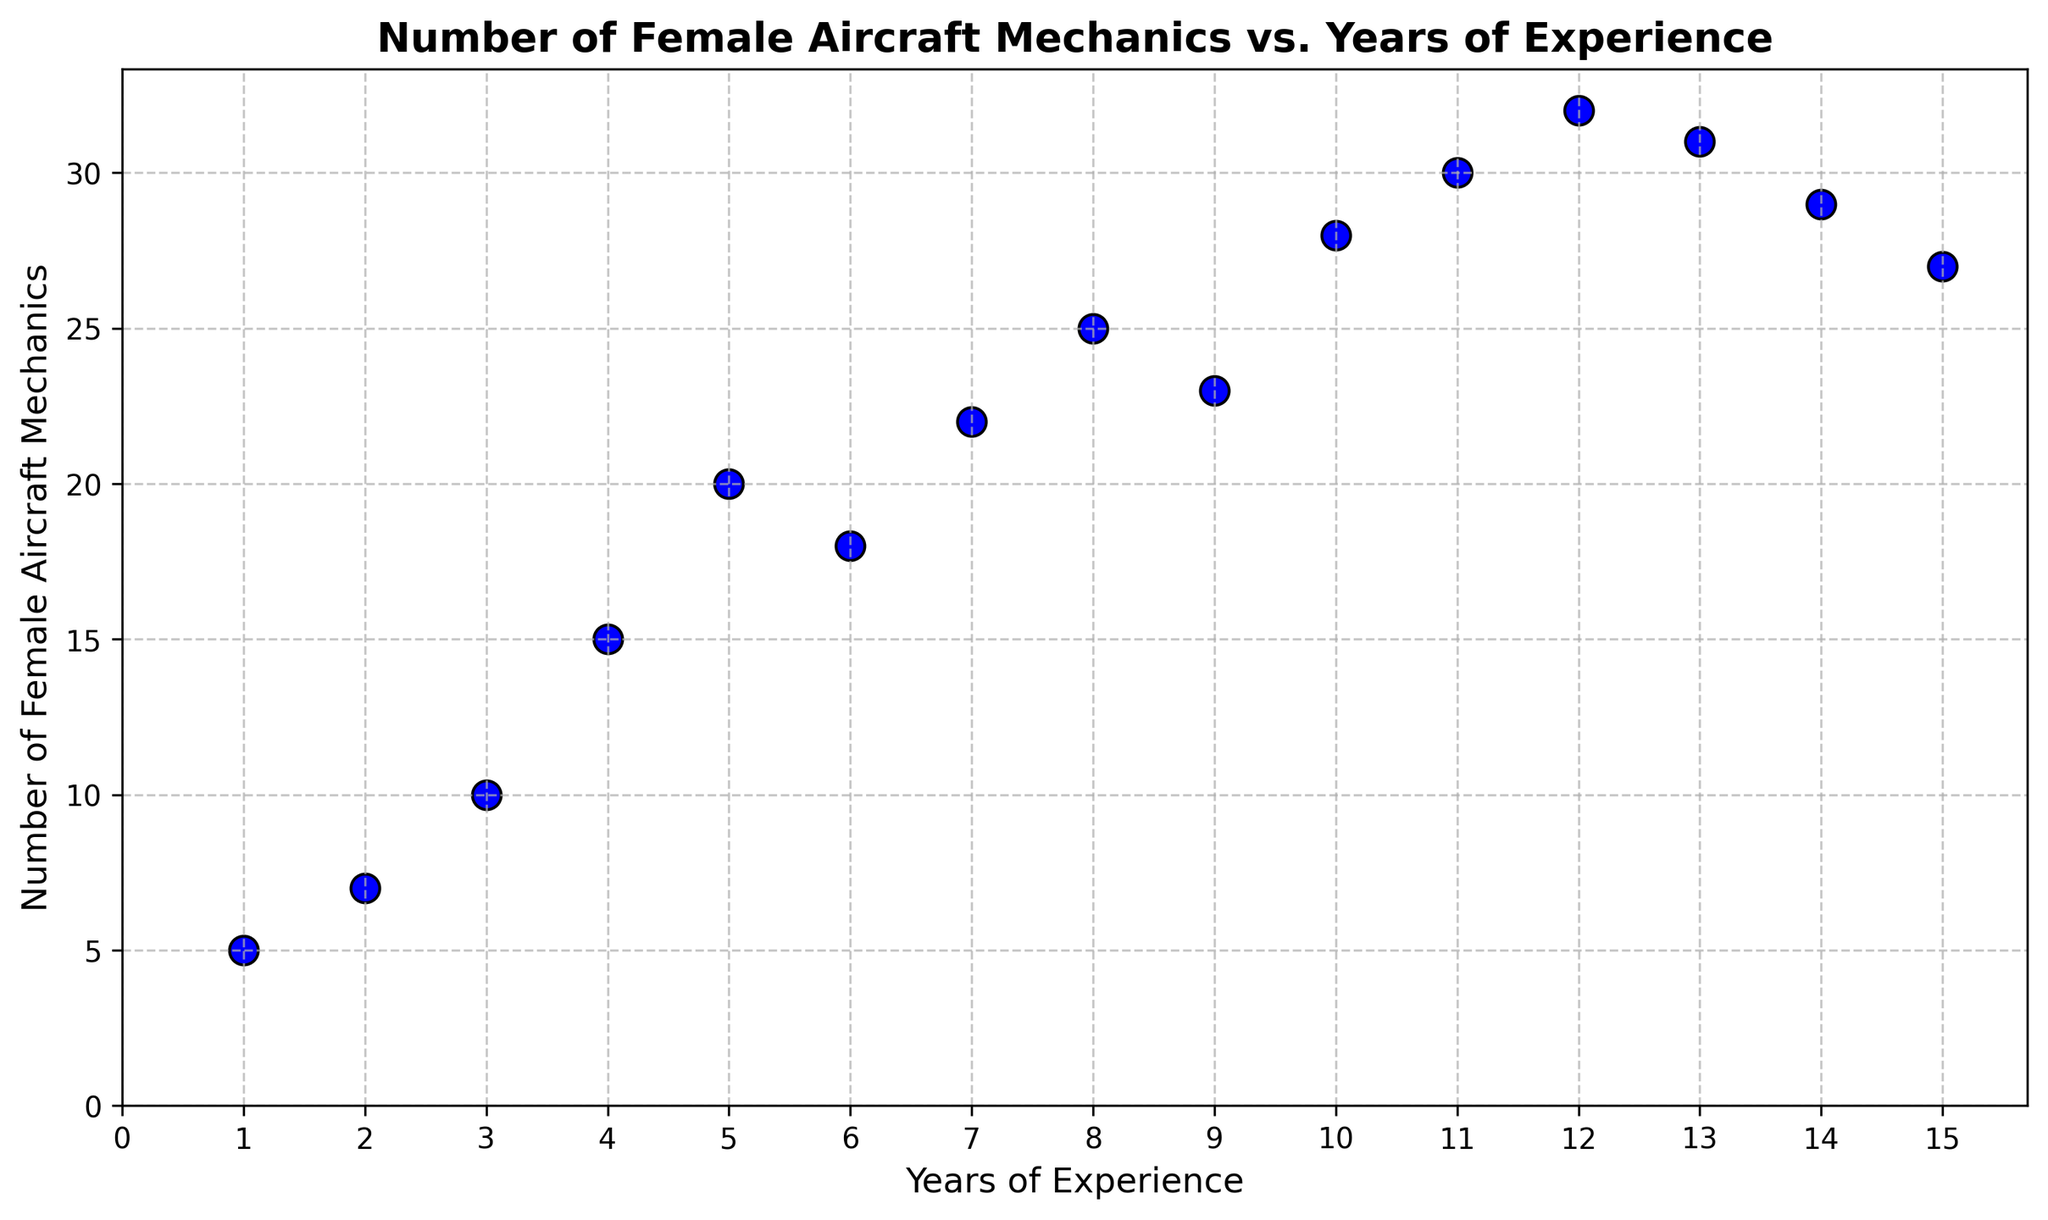What is the general trend of the number of female aircraft mechanics with increasing years of experience? The general trend is observed by looking at the direction of the scatter points from left to right. There is an upward trend with some fluctuations, indicating that the number of female aircraft mechanics generally increases with years of experience but reaches a peak and then slightly declines.
Answer: Increases initially, peaks, then slightly declines What is the minimum number of female aircraft mechanics, and at how many years of experience does this occur? To find the minimum, look for the lowest point on the y-axis. The minimum number of 5 mechanics occurs at 1 year of experience.
Answer: 5, at 1 year How many female aircraft mechanics are there at the mid-point of the data range in terms of years of experience? The midpoint for the years of experience is (1+15)/2 = 8. At 8 years of experience, the number of female aircraft mechanics is 25, as shown by the scatter point.
Answer: 25 Which single year of experience has the highest number of female aircraft mechanics? Identify the highest scatter point on the y-axis. This corresponds to the year with the largest value of female aircraft mechanics, which is 32 at 12 years of experience.
Answer: 32, at 12 years Is the number of female aircraft mechanics at 10 years of experience greater than that at 5 years? Compare the height of the scatter points for 5 and 10 years on the y-axis. At 5 years there are 20 mechanics, and at 10 years there are 28 mechanics. So, 10 years has a greater number.
Answer: Yes What is the average number of female aircraft mechanics for the first 5 years of experience (1 to 5 years)? Sum the values for the first 5 years (5 + 7 + 10 + 15 + 20 = 57) and divide by 5. The average is 57/5 = 11.4.
Answer: 11.4 By how much does the number of female aircraft mechanics increase from 1 to 3 years of experience? Subtract the number at 1 year from the number at 3 years (10 - 5 = 5). Therefore, the increase is 5 mechanics.
Answer: 5 Does the number of female aircraft mechanics ever decrease with increasing years of experience? If so, at which points does this occur? Compare consecutive data points to find any decrease. There is a decrease from 20 at 5 years to 18 at 6 years, from 25 at 8 years to 23 at 9 years, from 32 at 12 years to 31 at 13 years, from 31 at 13 years to 29 at 14 years, and from 29 at 14 years to 27 at 15 years.
Answer: Yes, at 6, 9, 13, 14, 15 years What is the total number of female aircraft mechanics from 1 to 15 years of experience? Sum all the values from 1 to 15 years. Summing (5 + 7 + 10 + 15 + 20 + 18 + 22 + 25 + 23 + 28 + 30 + 32 + 31 + 29 + 27) results in a total of 322 mechanics.
Answer: 322 Is there any significant fluctuation in the data? If yes, around which years do these fluctuations occur? Look for sharp increases or decreases between consecutive points. Significant fluctuations occur around 5-6 years (decrease), 9-10 years (increase), and 12-13 years (decrease).
Answer: Yes, around 5-6, 9-10, and 12-13 years 